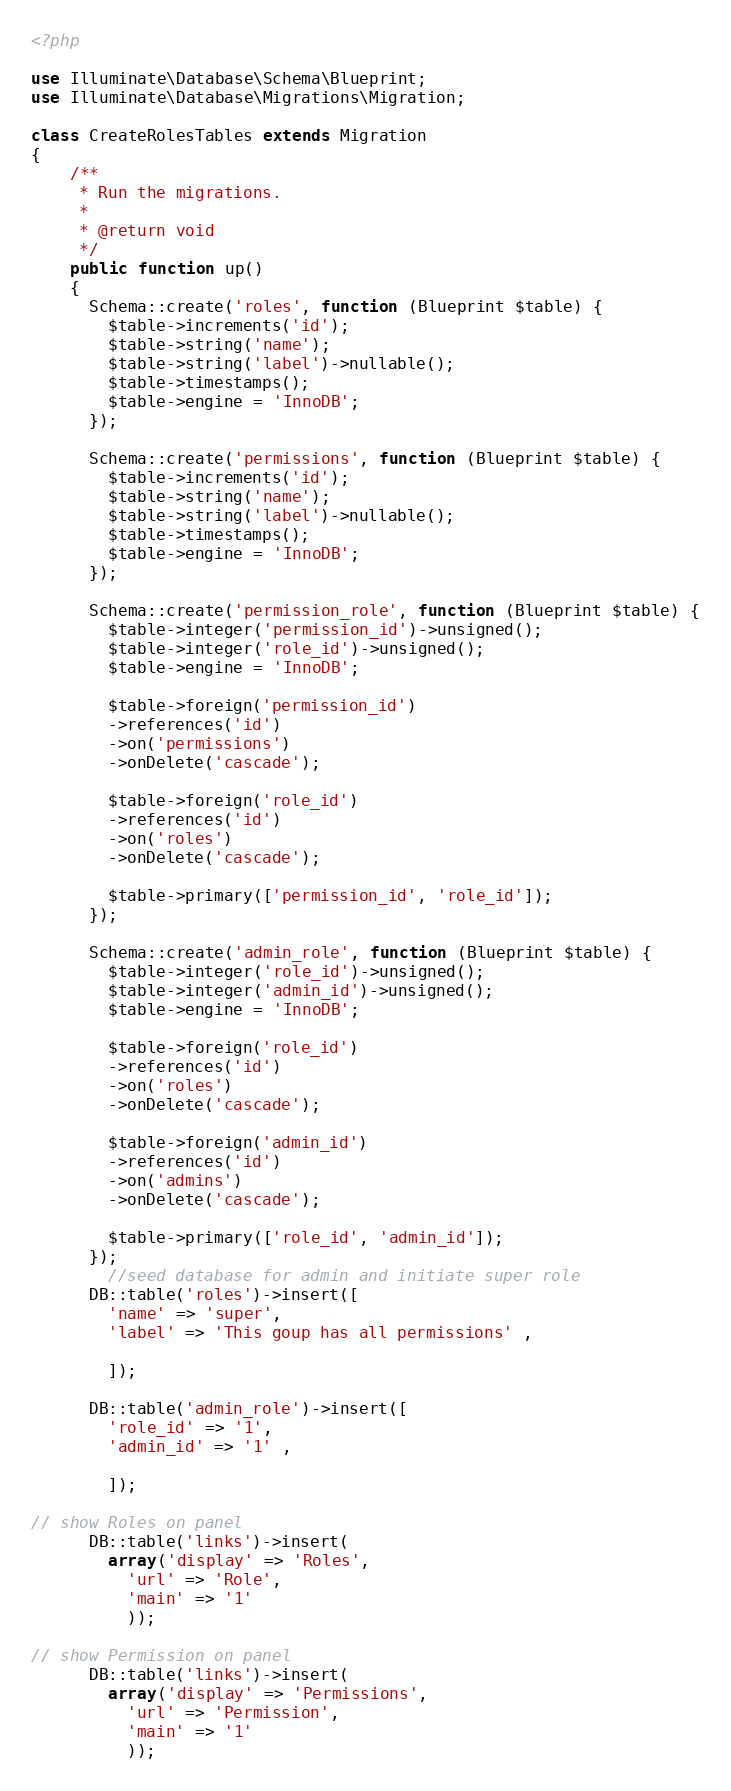Convert code to text. <code><loc_0><loc_0><loc_500><loc_500><_PHP_><?php

use Illuminate\Database\Schema\Blueprint;
use Illuminate\Database\Migrations\Migration;

class CreateRolesTables extends Migration
{
    /**
     * Run the migrations.
     *
     * @return void
     */
    public function up()
    {
      Schema::create('roles', function (Blueprint $table) {
        $table->increments('id');
        $table->string('name');
        $table->string('label')->nullable();
        $table->timestamps();
        $table->engine = 'InnoDB';
      });

      Schema::create('permissions', function (Blueprint $table) {
        $table->increments('id');
        $table->string('name');
        $table->string('label')->nullable();
        $table->timestamps();
        $table->engine = 'InnoDB';
      });

      Schema::create('permission_role', function (Blueprint $table) {
        $table->integer('permission_id')->unsigned();
        $table->integer('role_id')->unsigned();
        $table->engine = 'InnoDB';

        $table->foreign('permission_id')
        ->references('id')
        ->on('permissions')
        ->onDelete('cascade');

        $table->foreign('role_id')
        ->references('id')
        ->on('roles')
        ->onDelete('cascade');

        $table->primary(['permission_id', 'role_id']);
      });

      Schema::create('admin_role', function (Blueprint $table) {
        $table->integer('role_id')->unsigned();
        $table->integer('admin_id')->unsigned();
        $table->engine = 'InnoDB';

        $table->foreign('role_id')
        ->references('id')
        ->on('roles')
        ->onDelete('cascade');

        $table->foreign('admin_id')
        ->references('id')
        ->on('admins')
        ->onDelete('cascade');

        $table->primary(['role_id', 'admin_id']);
      });
    	//seed database for admin and initiate super role
      DB::table('roles')->insert([
        'name' => 'super',
        'label' => 'This goup has all permissions' ,

        ]);

      DB::table('admin_role')->insert([
        'role_id' => '1',
        'admin_id' => '1' ,

        ]);

// show Roles on panel
      DB::table('links')->insert(
        array('display' => 'Roles',
          'url' => 'Role', 
          'main' => '1'
          ));

// show Permission on panel
      DB::table('links')->insert(
        array('display' => 'Permissions',
          'url' => 'Permission', 
          'main' => '1'
          ));
</code> 